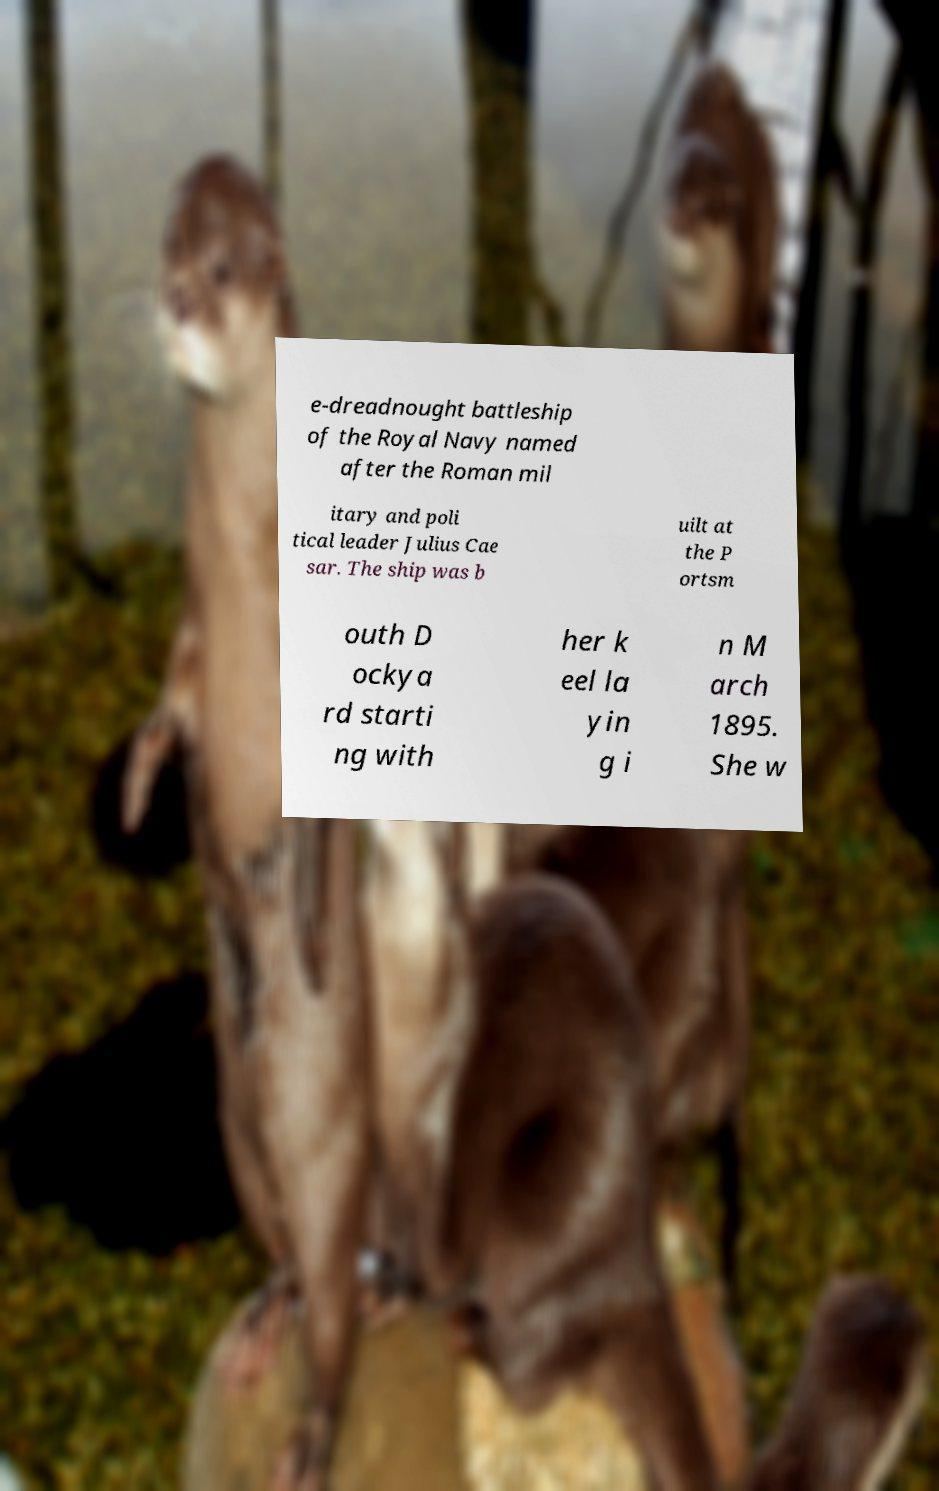There's text embedded in this image that I need extracted. Can you transcribe it verbatim? e-dreadnought battleship of the Royal Navy named after the Roman mil itary and poli tical leader Julius Cae sar. The ship was b uilt at the P ortsm outh D ockya rd starti ng with her k eel la yin g i n M arch 1895. She w 